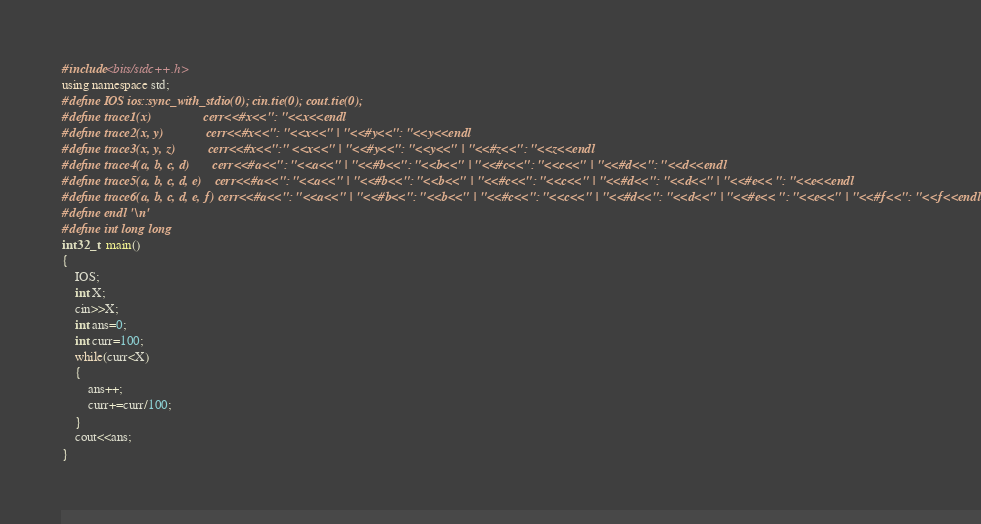Convert code to text. <code><loc_0><loc_0><loc_500><loc_500><_C++_>#include<bits/stdc++.h>
using namespace std;
#define IOS ios::sync_with_stdio(0); cin.tie(0); cout.tie(0);
#define trace1(x)                cerr<<#x<<": "<<x<<endl
#define trace2(x, y)             cerr<<#x<<": "<<x<<" | "<<#y<<": "<<y<<endl
#define trace3(x, y, z)          cerr<<#x<<":" <<x<<" | "<<#y<<": "<<y<<" | "<<#z<<": "<<z<<endl
#define trace4(a, b, c, d)       cerr<<#a<<": "<<a<<" | "<<#b<<": "<<b<<" | "<<#c<<": "<<c<<" | "<<#d<<": "<<d<<endl
#define trace5(a, b, c, d, e)    cerr<<#a<<": "<<a<<" | "<<#b<<": "<<b<<" | "<<#c<<": "<<c<<" | "<<#d<<": "<<d<<" | "<<#e<< ": "<<e<<endl
#define trace6(a, b, c, d, e, f) cerr<<#a<<": "<<a<<" | "<<#b<<": "<<b<<" | "<<#c<<": "<<c<<" | "<<#d<<": "<<d<<" | "<<#e<< ": "<<e<<" | "<<#f<<": "<<f<<endl
#define endl '\n'
#define int long long
int32_t  main()
{
    IOS;  
    int X;
    cin>>X;  
    int ans=0;
    int curr=100;
    while(curr<X)
    {
        ans++;
        curr+=curr/100;
    }
    cout<<ans;  
}</code> 